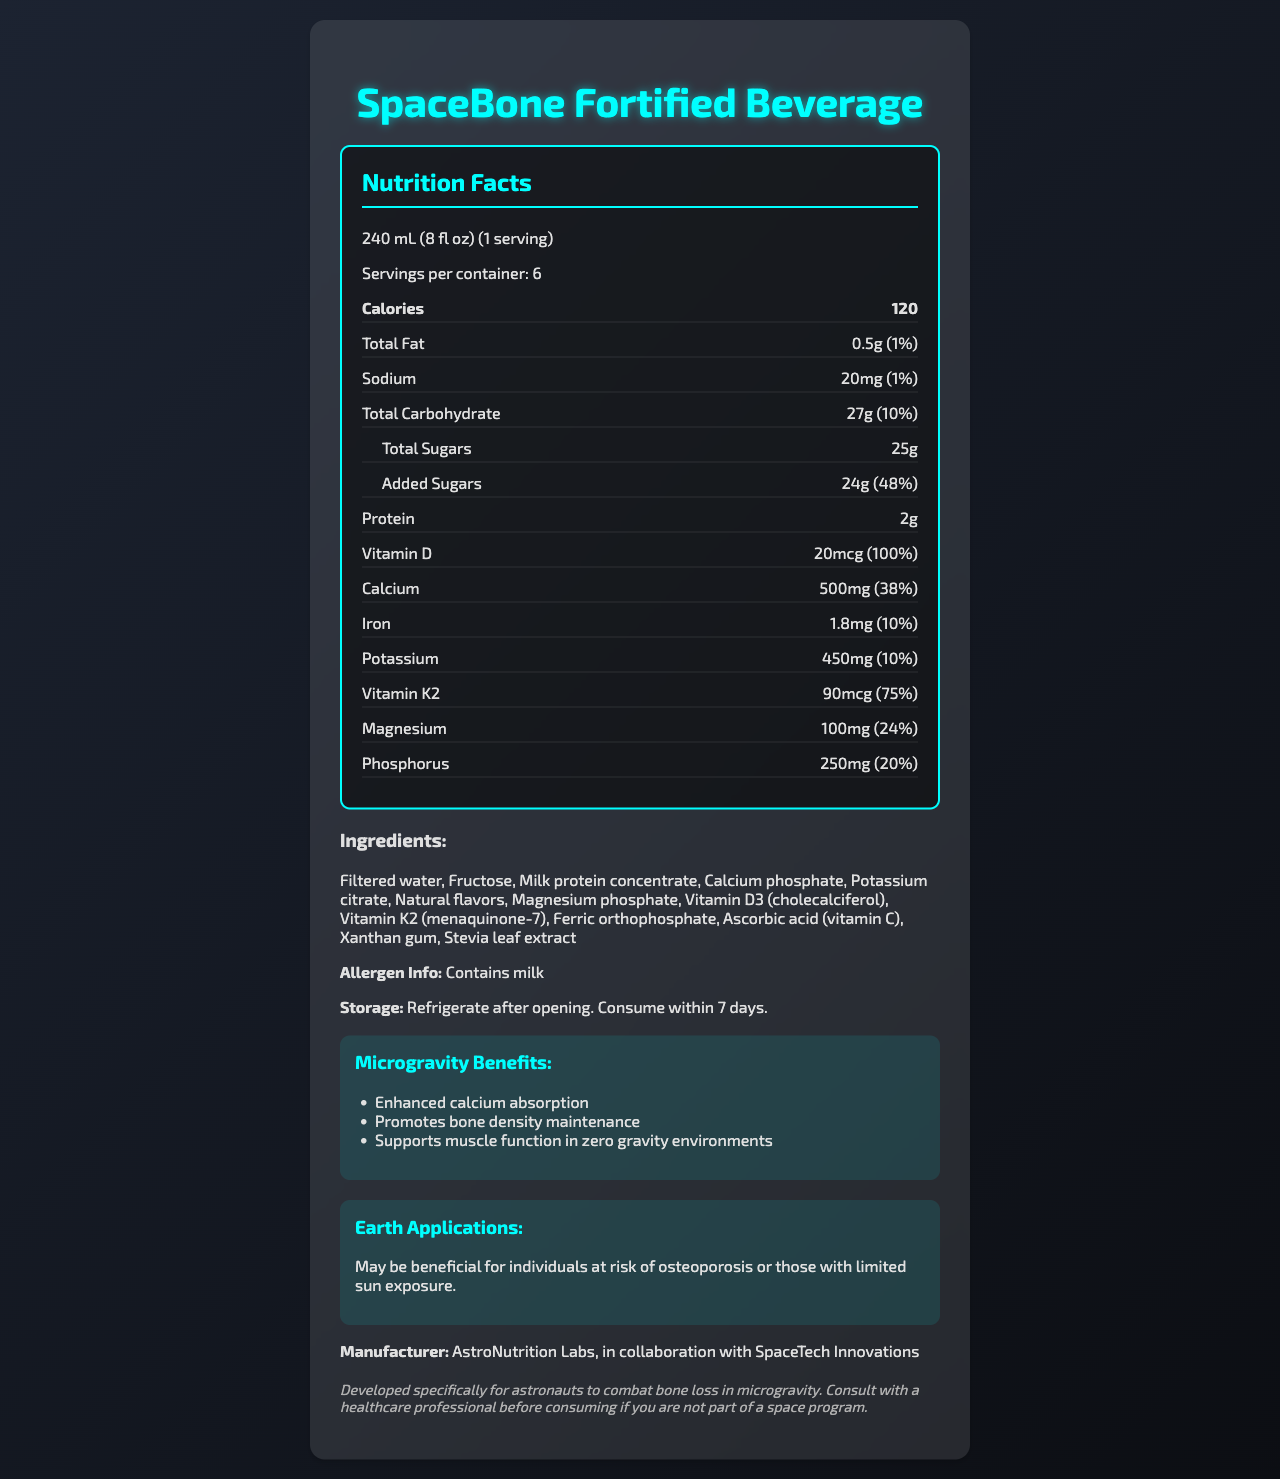what is the serving size for SpaceBone Fortified Beverage? The document states that the serving size for SpaceBone Fortified Beverage is 240 mL (8 fl oz).
Answer: 240 mL (8 fl oz) How many servings are there per container? The document specifies there are 6 servings per container.
Answer: 6 How many calories are in one serving? The document mentions that one serving contains 120 calories.
Answer: 120 What percentage of the daily value of calcium is provided by one serving? The label indicates that one serving of the beverage provides 38% of the daily value of calcium.
Answer: 38% Which vitamin in the product provides 100% of the daily value? The nutrition label shows that Vitamin D in the product provides 100% of the daily value.
Answer: Vitamin D How much added sugar is in one serving? According to the document, one serving has 24g of added sugars.
Answer: 24g What is the main benefit of the SpaceBone Fortified Beverage in microgravity environments? A. Supports muscle function B. Enhances calcium absorption C. Reduces body weight D. Improves sleep quality The document lists "Enhanced calcium absorption" as one of the microgravity benefits.
Answer: B. Enhances calcium absorption How long should the SpaceBone Fortified Beverage be consumed after opening? A. 2 days B. 5 days C. 7 days D. 10 days The document advises to consume the beverage within 7 days after opening.
Answer: C. 7 days Does the product contain any allergens? The product contains milk as noted under the allergen info.
Answer: Yes What is the main idea of the document? The document summarizes the product, its nutrition, composition, and special benefits for both space and Earth applications.
Answer: The document provides detailed nutrition facts, ingredient information, and benefits of the SpaceBone Fortified Beverage, which is designed to combat bone loss in microgravity environments and may also be beneficial on Earth. Is Fructose one of the ingredients in the SpaceBone Fortified Beverage? The document lists Fructose as one of the ingredients.
Answer: Yes Who manufactures the SpaceBone Fortified Beverage? The document states that the beverage is manufactured by AstroNutrition Labs, in collaboration with SpaceTech Innovations.
Answer: AstroNutrition Labs, in collaboration with SpaceTech Innovations What are the Earth applications of the SpaceBone Fortified Beverage? The document indicates that the beverage may be advantageous for individuals at risk of osteoporosis or with limited sun exposure on Earth.
Answer: May be beneficial for individuals at risk of osteoporosis or those with limited sun exposure. What is the amount of potassium in one serving? The nutrition label specifies that one serving contains 450mg of Potassium.
Answer: 450mg Can the exact market price for the SpaceBone Fortified Beverage be determined from the document? The document does not provide any price information for the beverage.
Answer: Not enough information 